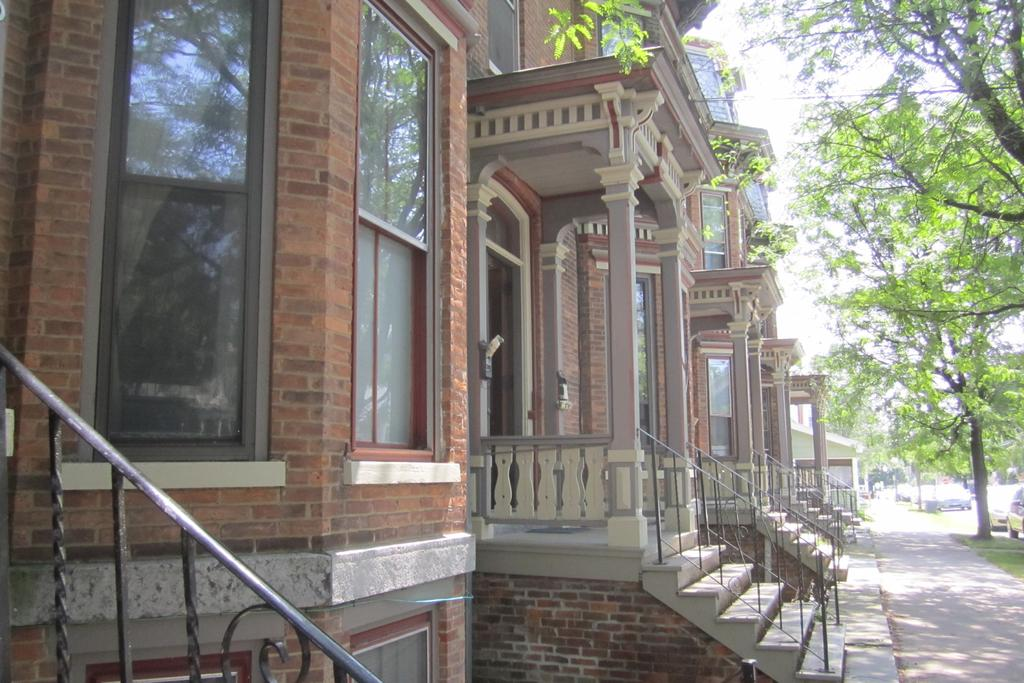What structures are located on the left side of the image? There are buildings on the left side of the image. What type of vegetation is on the right side of the image? There are trees on the right side of the image. What can be seen behind the trees in the image? There are vehicles visible behind the trees on a road. Where is the church located in the image? There is no church present in the image. What type of calculator can be seen on the road behind the trees? There is no calculator present in the image. 